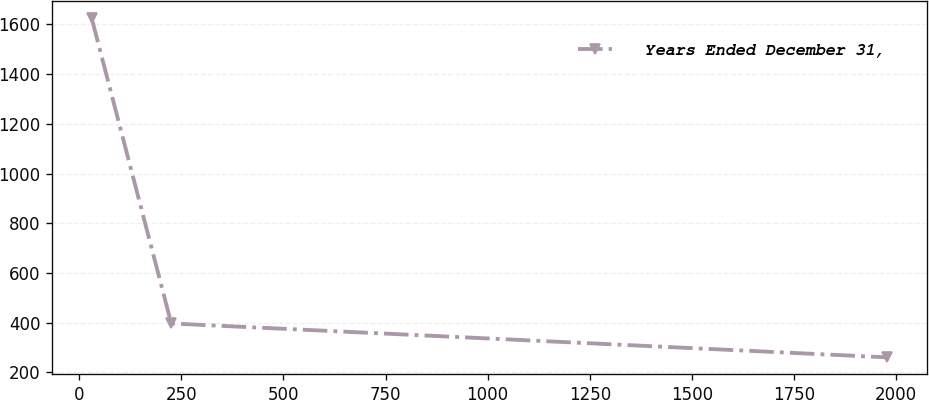Convert chart. <chart><loc_0><loc_0><loc_500><loc_500><line_chart><ecel><fcel>Years Ended December 31,<nl><fcel>30.63<fcel>1624.33<nl><fcel>225.34<fcel>397.21<nl><fcel>1977.73<fcel>260.86<nl></chart> 